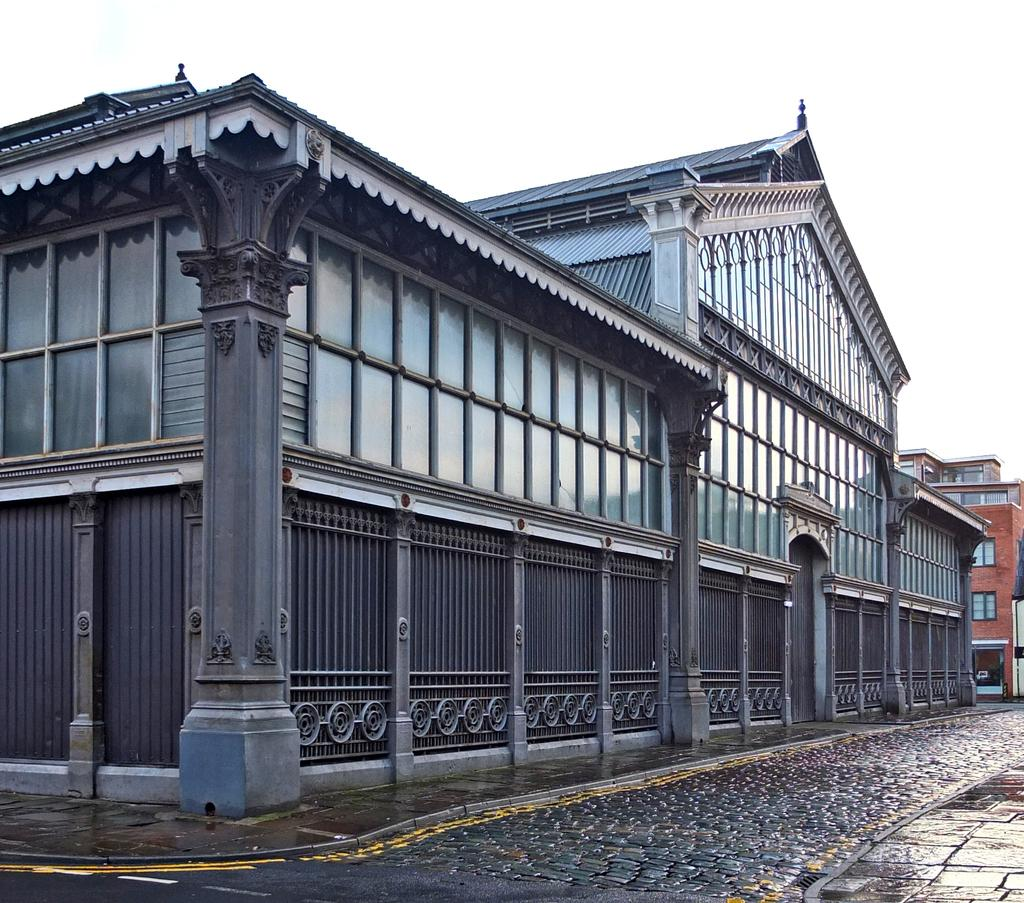What type of structures can be seen in the image? There are buildings in the image. What is visible at the bottom of the image? The ground is visible in the image. What is visible at the top of the image? The sky is visible in the image. What type of shape is the zinc taking in the image? There is no zinc present in the image, so it is not possible to determine its shape. 